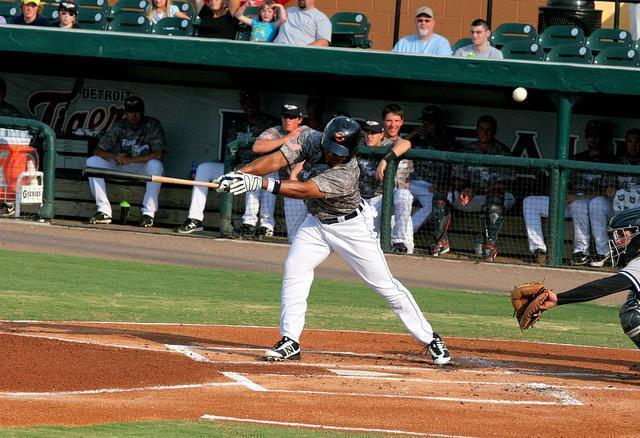What is the man with the bat about to do?
Pick the right solution, then justify: 'Answer: answer
Rationale: rationale.'
Options: Sit, duck, swing, sing. Answer: swing.
Rationale: The man is clearly a baseball batter based on his equipment and positioning and his intention is to swing and hit the ball. 